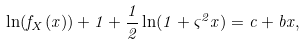Convert formula to latex. <formula><loc_0><loc_0><loc_500><loc_500>\ln ( { { f _ { X } } ( x ) } ) + 1 + \frac { 1 } { 2 } \ln ( 1 + { \varsigma ^ { 2 } } x ) = c + b x ,</formula> 